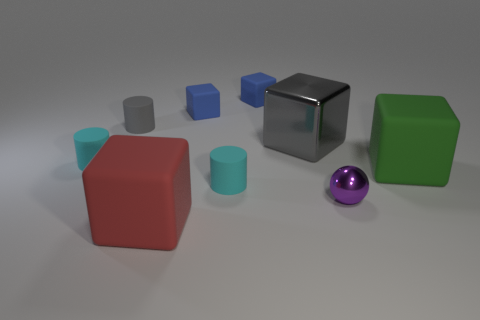Add 1 brown shiny balls. How many objects exist? 10 Subtract all gray rubber cylinders. How many cylinders are left? 2 Subtract 1 cylinders. How many cylinders are left? 2 Subtract all cyan cylinders. How many cylinders are left? 1 Subtract all spheres. How many objects are left? 8 Subtract 1 green blocks. How many objects are left? 8 Subtract all yellow cylinders. Subtract all brown cubes. How many cylinders are left? 3 Subtract all purple spheres. How many blue cubes are left? 2 Subtract all small cyan rubber things. Subtract all large rubber cubes. How many objects are left? 5 Add 5 green rubber objects. How many green rubber objects are left? 6 